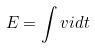<formula> <loc_0><loc_0><loc_500><loc_500>E = \int v i d t</formula> 